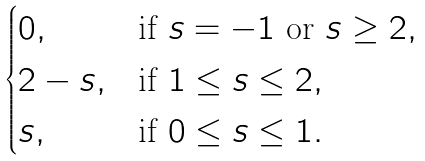<formula> <loc_0><loc_0><loc_500><loc_500>\begin{cases} 0 , & \text {if $s = -1$ or $s \geq 2$} , \\ 2 - s , & \text {if $1 \leq s \leq 2$} , \\ s , & \text {if $0 \leq s \leq 1$} . \end{cases}</formula> 